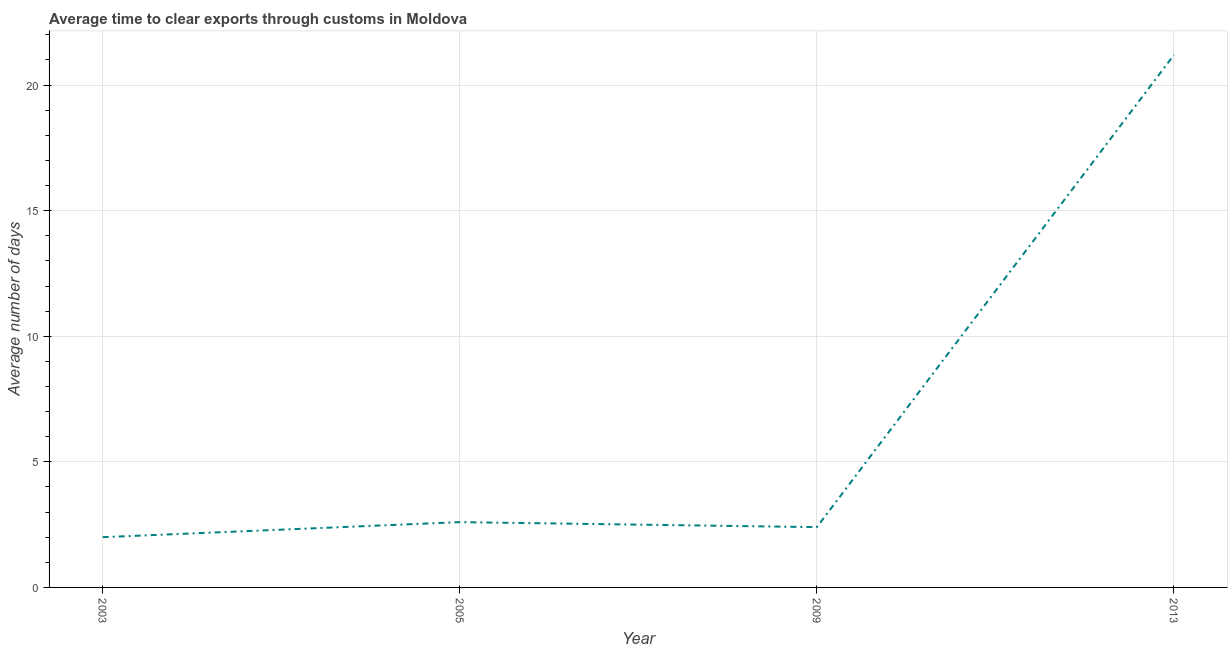What is the time to clear exports through customs in 2009?
Offer a terse response. 2.4. Across all years, what is the maximum time to clear exports through customs?
Your answer should be very brief. 21.2. In which year was the time to clear exports through customs minimum?
Offer a terse response. 2003. What is the sum of the time to clear exports through customs?
Keep it short and to the point. 28.2. What is the difference between the time to clear exports through customs in 2009 and 2013?
Provide a short and direct response. -18.8. What is the average time to clear exports through customs per year?
Your answer should be compact. 7.05. In how many years, is the time to clear exports through customs greater than 1 days?
Offer a terse response. 4. Do a majority of the years between 2009 and 2005 (inclusive) have time to clear exports through customs greater than 6 days?
Keep it short and to the point. No. What is the ratio of the time to clear exports through customs in 2009 to that in 2013?
Offer a terse response. 0.11. Is the time to clear exports through customs in 2005 less than that in 2013?
Your answer should be very brief. Yes. Is the difference between the time to clear exports through customs in 2005 and 2013 greater than the difference between any two years?
Your response must be concise. No. What is the difference between the highest and the second highest time to clear exports through customs?
Provide a succinct answer. 18.6. Is the sum of the time to clear exports through customs in 2003 and 2005 greater than the maximum time to clear exports through customs across all years?
Provide a short and direct response. No. What is the difference between the highest and the lowest time to clear exports through customs?
Offer a very short reply. 19.2. In how many years, is the time to clear exports through customs greater than the average time to clear exports through customs taken over all years?
Ensure brevity in your answer.  1. Are the values on the major ticks of Y-axis written in scientific E-notation?
Offer a terse response. No. Does the graph contain any zero values?
Provide a succinct answer. No. What is the title of the graph?
Your answer should be compact. Average time to clear exports through customs in Moldova. What is the label or title of the Y-axis?
Offer a very short reply. Average number of days. What is the Average number of days of 2009?
Keep it short and to the point. 2.4. What is the Average number of days in 2013?
Your answer should be compact. 21.2. What is the difference between the Average number of days in 2003 and 2009?
Provide a succinct answer. -0.4. What is the difference between the Average number of days in 2003 and 2013?
Give a very brief answer. -19.2. What is the difference between the Average number of days in 2005 and 2009?
Keep it short and to the point. 0.2. What is the difference between the Average number of days in 2005 and 2013?
Keep it short and to the point. -18.6. What is the difference between the Average number of days in 2009 and 2013?
Provide a succinct answer. -18.8. What is the ratio of the Average number of days in 2003 to that in 2005?
Your answer should be very brief. 0.77. What is the ratio of the Average number of days in 2003 to that in 2009?
Give a very brief answer. 0.83. What is the ratio of the Average number of days in 2003 to that in 2013?
Your response must be concise. 0.09. What is the ratio of the Average number of days in 2005 to that in 2009?
Offer a terse response. 1.08. What is the ratio of the Average number of days in 2005 to that in 2013?
Your answer should be very brief. 0.12. What is the ratio of the Average number of days in 2009 to that in 2013?
Ensure brevity in your answer.  0.11. 